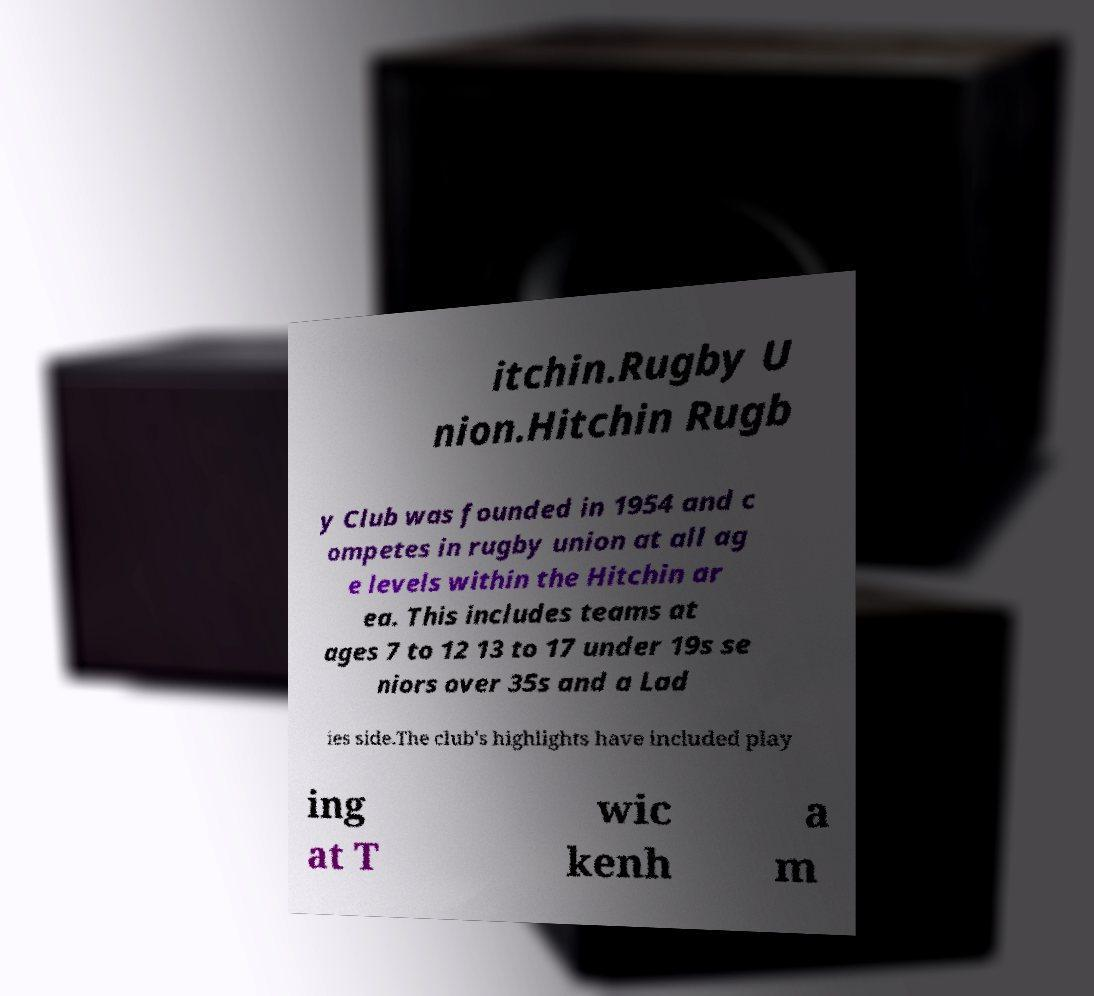I need the written content from this picture converted into text. Can you do that? itchin.Rugby U nion.Hitchin Rugb y Club was founded in 1954 and c ompetes in rugby union at all ag e levels within the Hitchin ar ea. This includes teams at ages 7 to 12 13 to 17 under 19s se niors over 35s and a Lad ies side.The club's highlights have included play ing at T wic kenh a m 